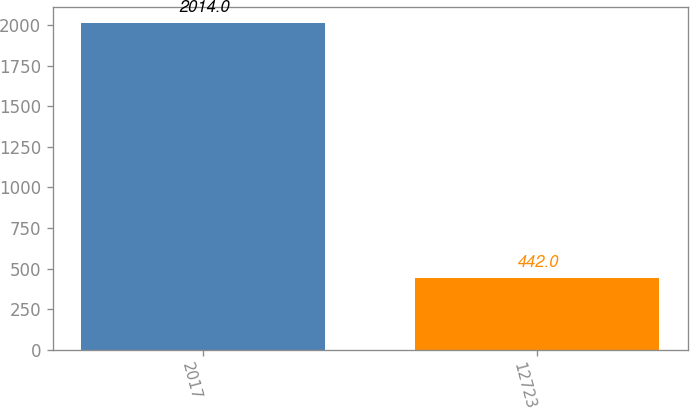<chart> <loc_0><loc_0><loc_500><loc_500><bar_chart><fcel>2017<fcel>12723<nl><fcel>2014<fcel>442<nl></chart> 